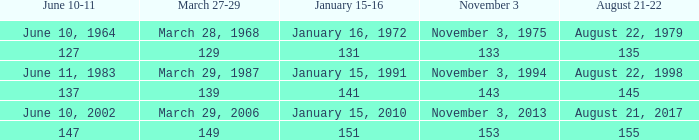What number is shown for november 3 where january 15-16 is 151? 153.0. 